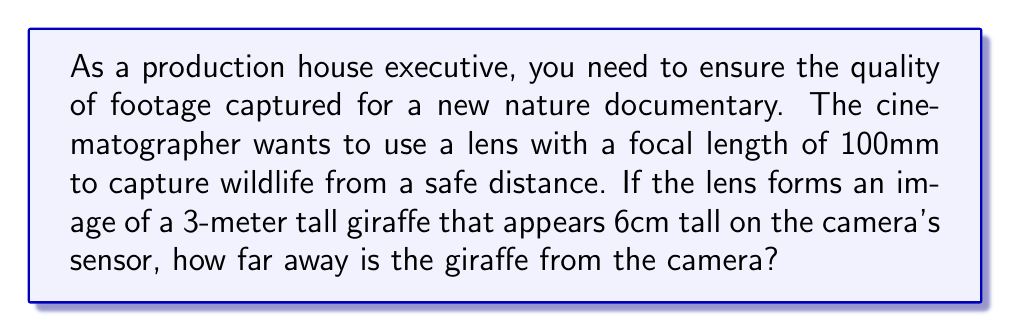What is the answer to this math problem? Let's approach this step-by-step using the thin lens equation and magnification formula:

1) The thin lens equation is:
   $$\frac{1}{f} = \frac{1}{u} + \frac{1}{v}$$
   where $f$ is the focal length, $u$ is the object distance, and $v$ is the image distance.

2) The magnification formula is:
   $$M = \frac{h_i}{h_o} = -\frac{v}{u}$$
   where $M$ is magnification, $h_i$ is image height, and $h_o$ is object height.

3) From the given information:
   $f = 100$ mm
   $h_o = 3$ m $= 3000$ mm
   $h_i = 6$ cm $= 60$ mm

4) Calculate the magnification:
   $$M = \frac{h_i}{h_o} = \frac{60}{3000} = -\frac{1}{50}$$
   The negative sign indicates an inverted image.

5) Using the magnification formula:
   $$-\frac{1}{50} = -\frac{v}{u}$$
   $$u = 50v$$

6) Substitute this into the thin lens equation:
   $$\frac{1}{100} = \frac{1}{50v} + \frac{1}{v}$$

7) Solve for $v$:
   $$\frac{1}{100} = \frac{51}{50v}$$
   $$v = \frac{51 \times 100}{50} = 102$ mm$$

8) Now we can find $u$:
   $$u = 50v = 50 \times 102 = 5100$ mm $= 5.1$ m

Therefore, the giraffe is 5.1 meters away from the camera.
Answer: 5.1 m 